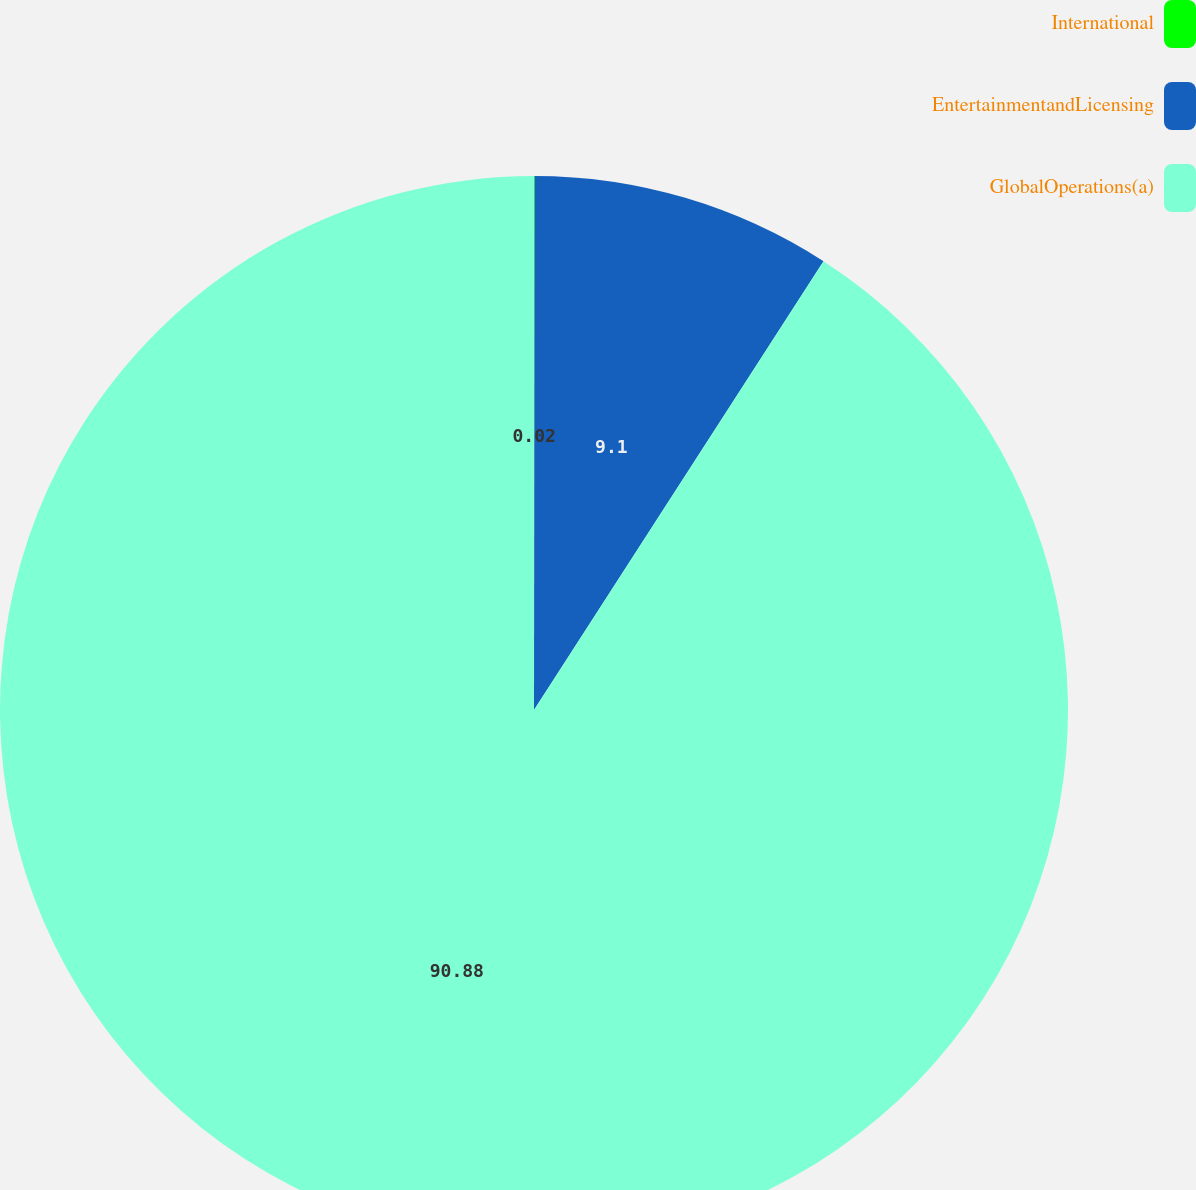<chart> <loc_0><loc_0><loc_500><loc_500><pie_chart><fcel>International<fcel>EntertainmentandLicensing<fcel>GlobalOperations(a)<nl><fcel>0.02%<fcel>9.1%<fcel>90.88%<nl></chart> 